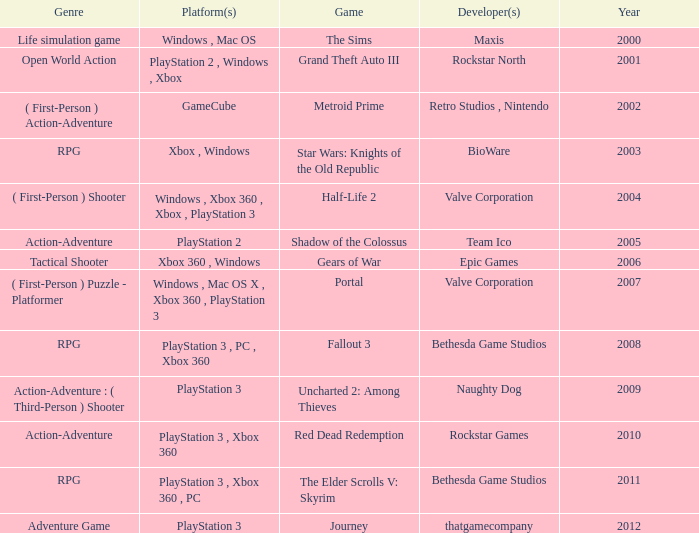What's the platform that has Rockstar Games as the developer? PlayStation 3 , Xbox 360. 